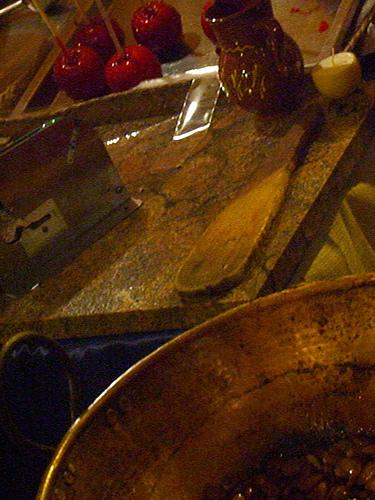Is this a tidy kitchen?
Concise answer only. No. Are these glazed apples?
Quick response, please. Yes. Is this a poor quality picture?
Answer briefly. No. 